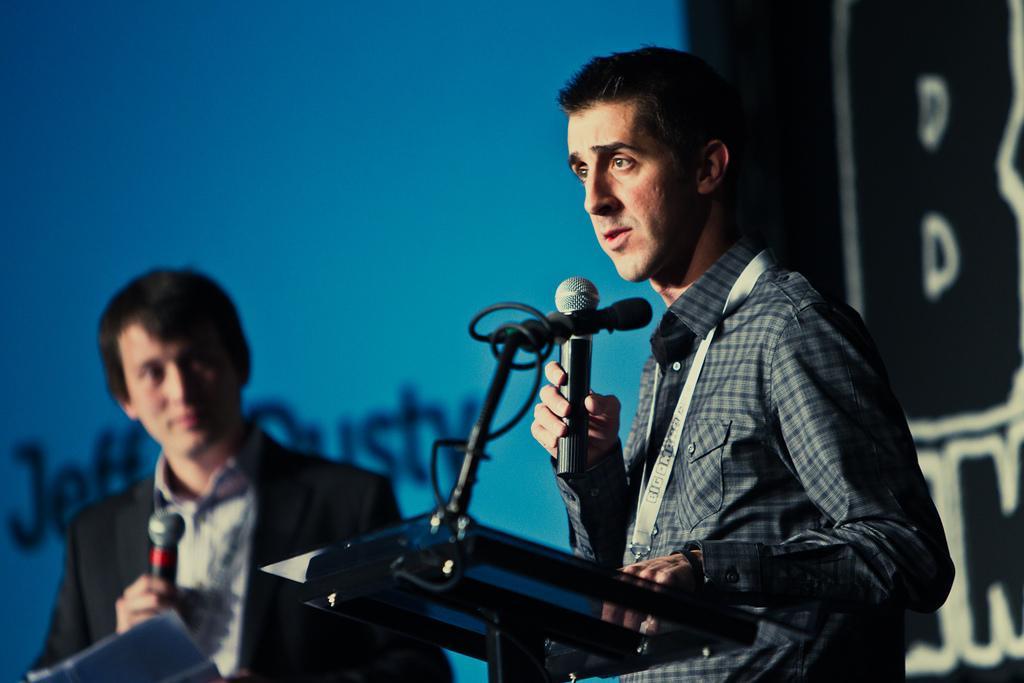Could you give a brief overview of what you see in this image? In the background we can see a banner. In this picture we can see the men standing and they both are holding microphones. At the bottom portion of the picture we can see a podium, paper, microphone and a wire. 